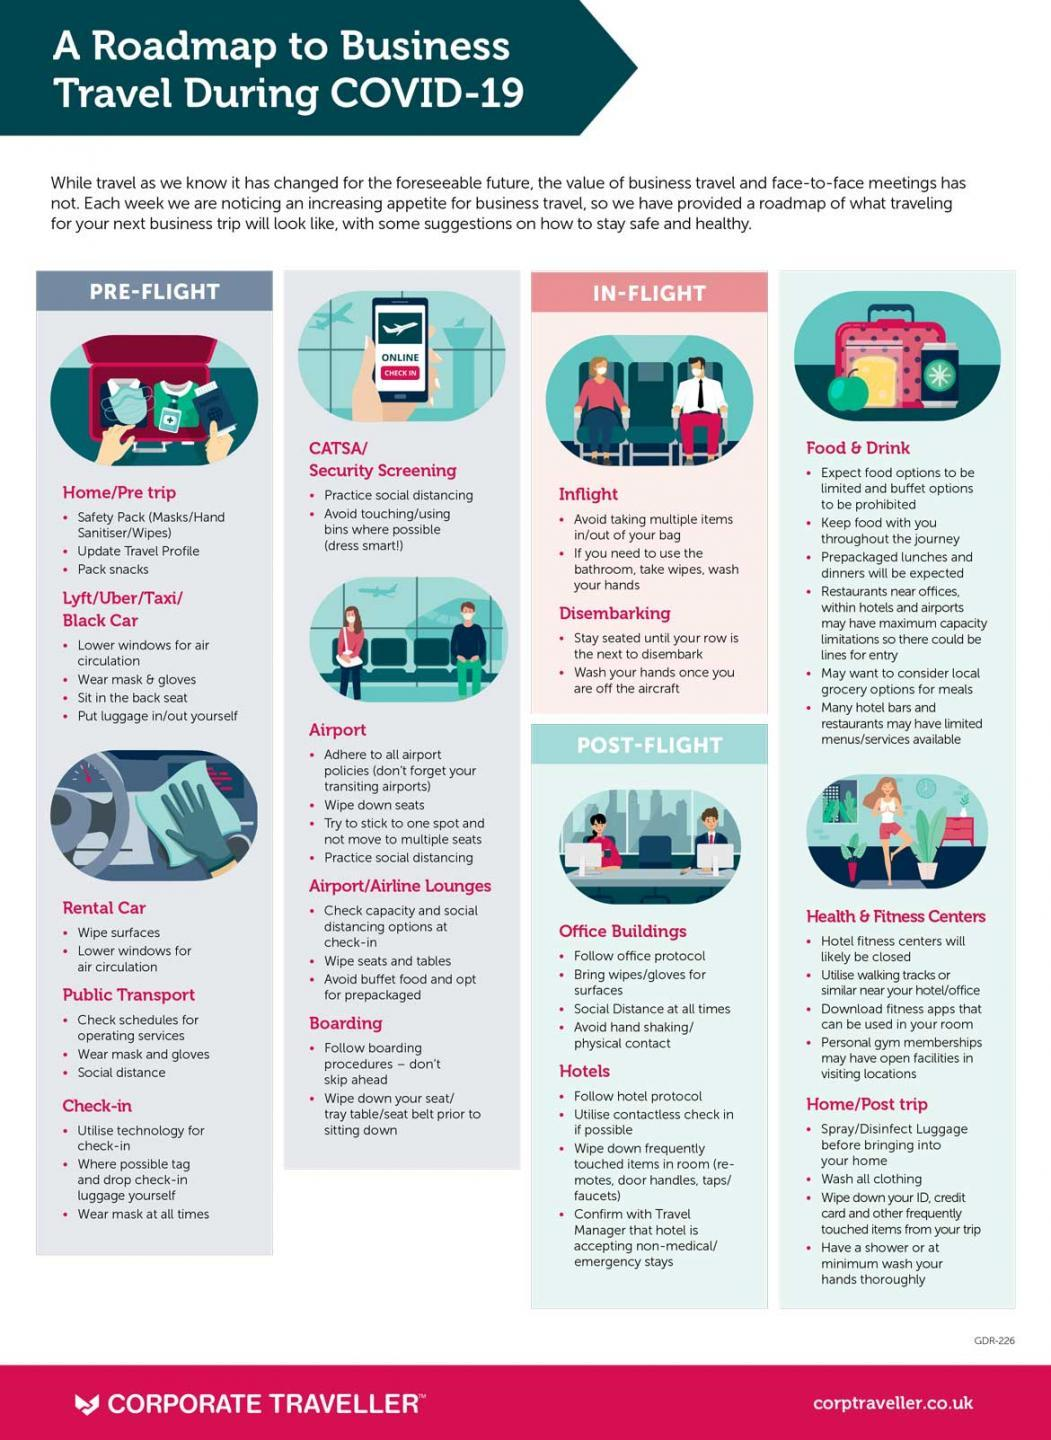Indicate a few pertinent items in this graphic. You should practice social distancing in five places. In three places, you should wear a mask. 